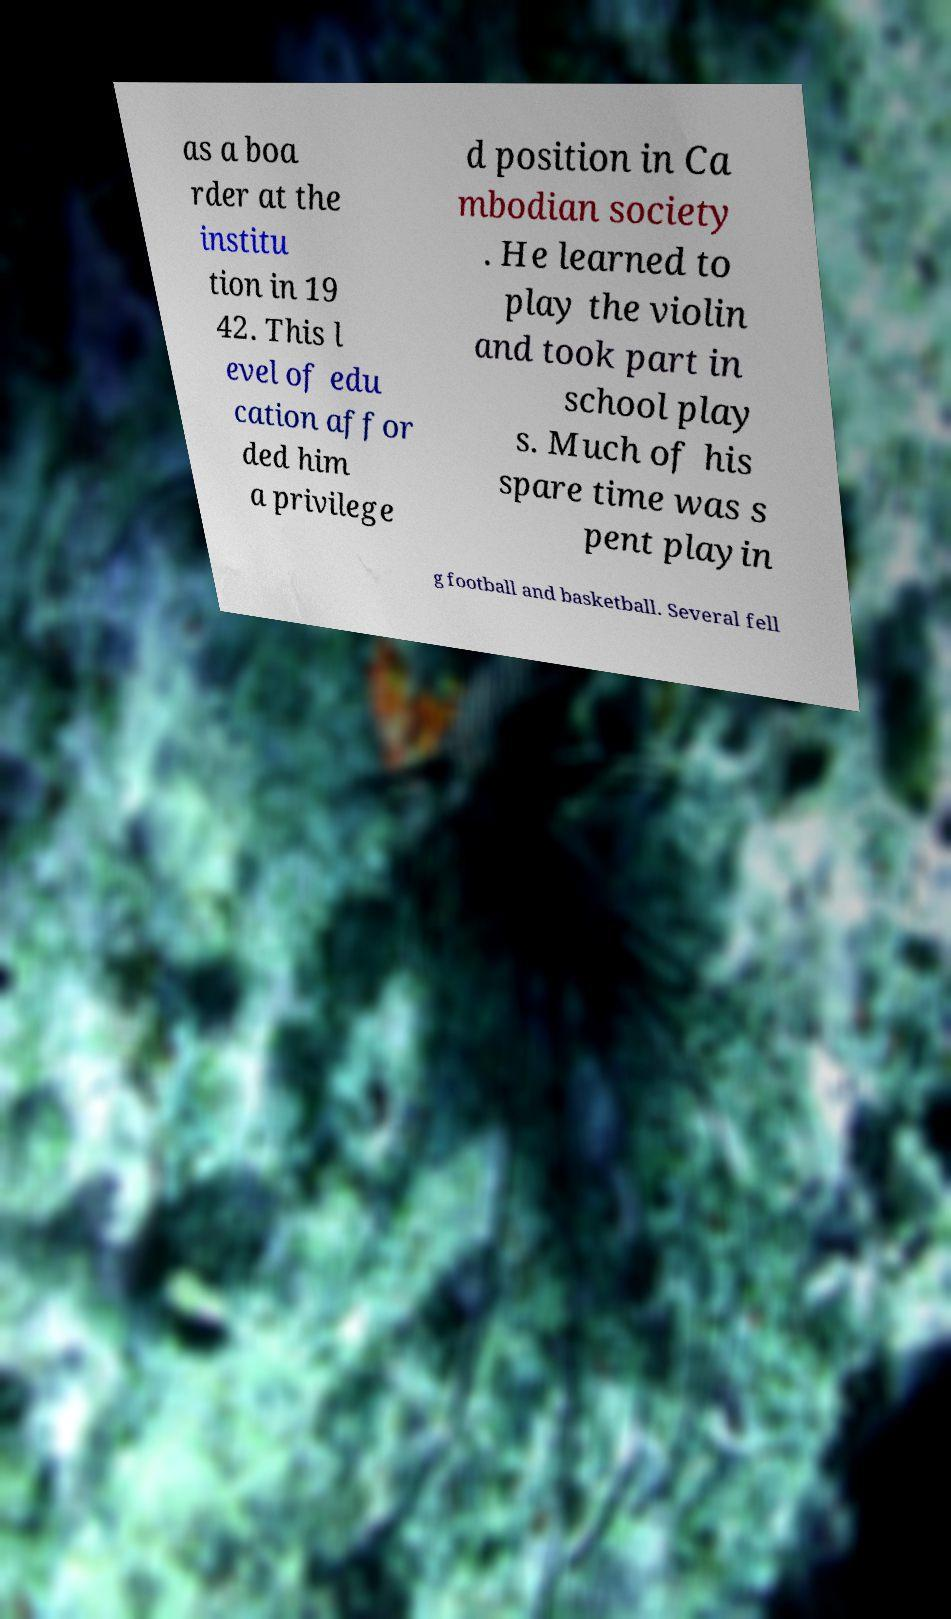Please identify and transcribe the text found in this image. as a boa rder at the institu tion in 19 42. This l evel of edu cation affor ded him a privilege d position in Ca mbodian society . He learned to play the violin and took part in school play s. Much of his spare time was s pent playin g football and basketball. Several fell 